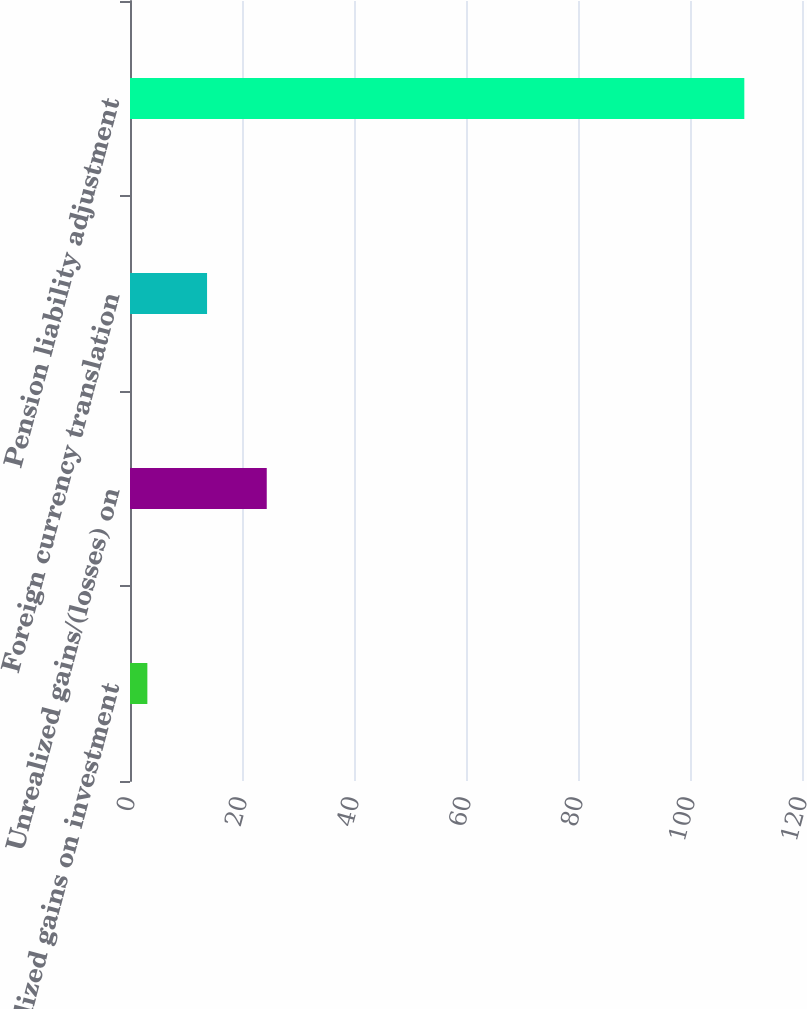Convert chart to OTSL. <chart><loc_0><loc_0><loc_500><loc_500><bar_chart><fcel>Unrealized gains on investment<fcel>Unrealized gains/(losses) on<fcel>Foreign currency translation<fcel>Pension liability adjustment<nl><fcel>3.1<fcel>24.42<fcel>13.76<fcel>109.7<nl></chart> 